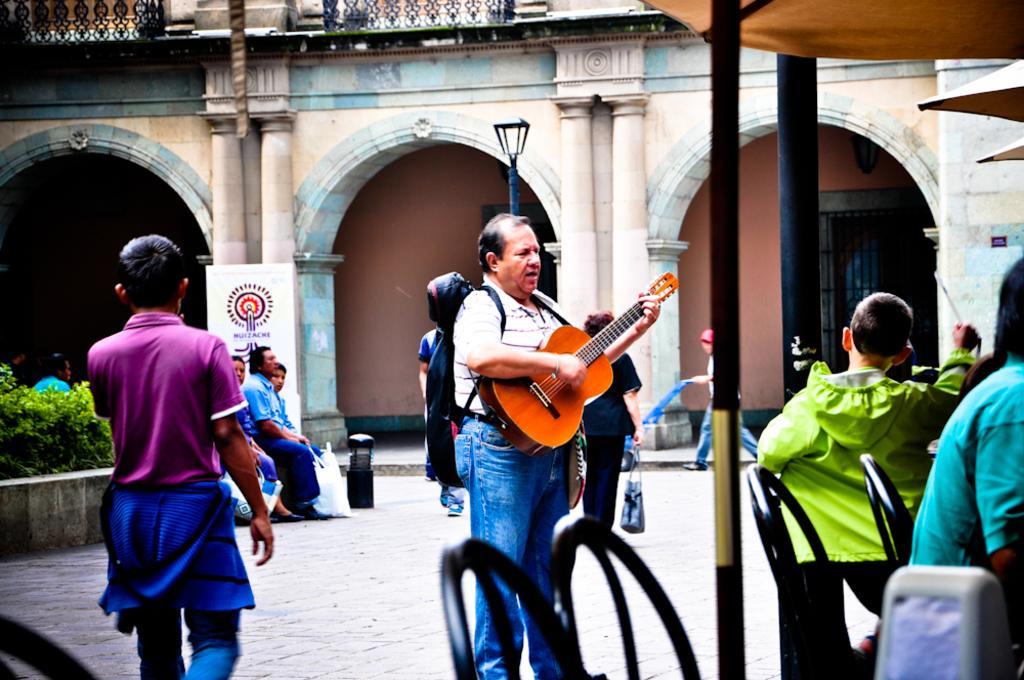Please provide a concise description of this image. Here we can see door and pillars. This is a building. We can see a board. We can see few persons sitting, some are walking. We can see a man here standing and playing guitar and singing. These are plants. 